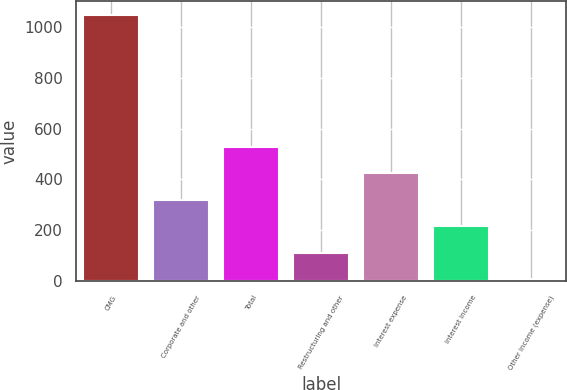<chart> <loc_0><loc_0><loc_500><loc_500><bar_chart><fcel>CMG<fcel>Corporate and other<fcel>Total<fcel>Restructuring and other<fcel>Interest expense<fcel>Interest income<fcel>Other income (expense)<nl><fcel>1048.5<fcel>320.5<fcel>528.5<fcel>112.5<fcel>424.5<fcel>216.5<fcel>8.5<nl></chart> 